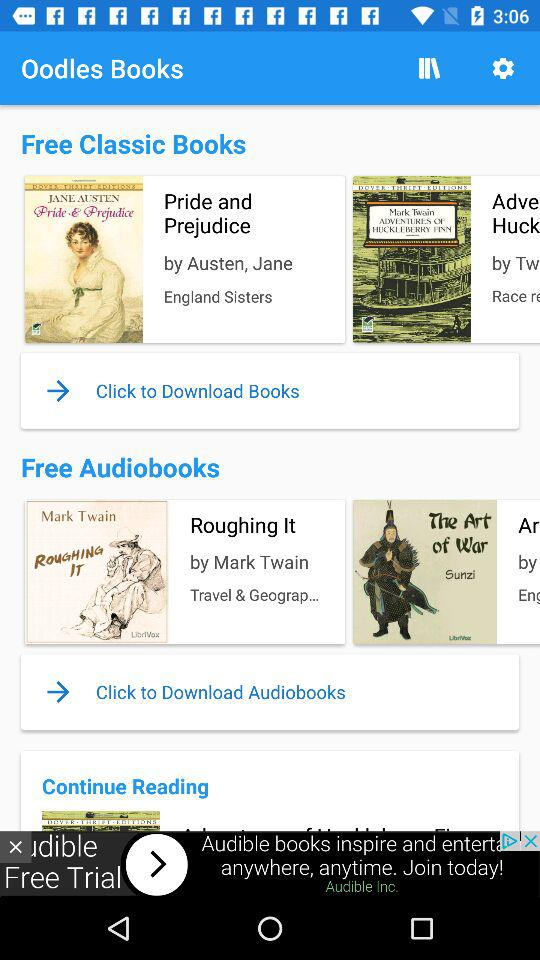What is the category of the book "Pride and Prejudice"? The category is "Free Classic Books". 